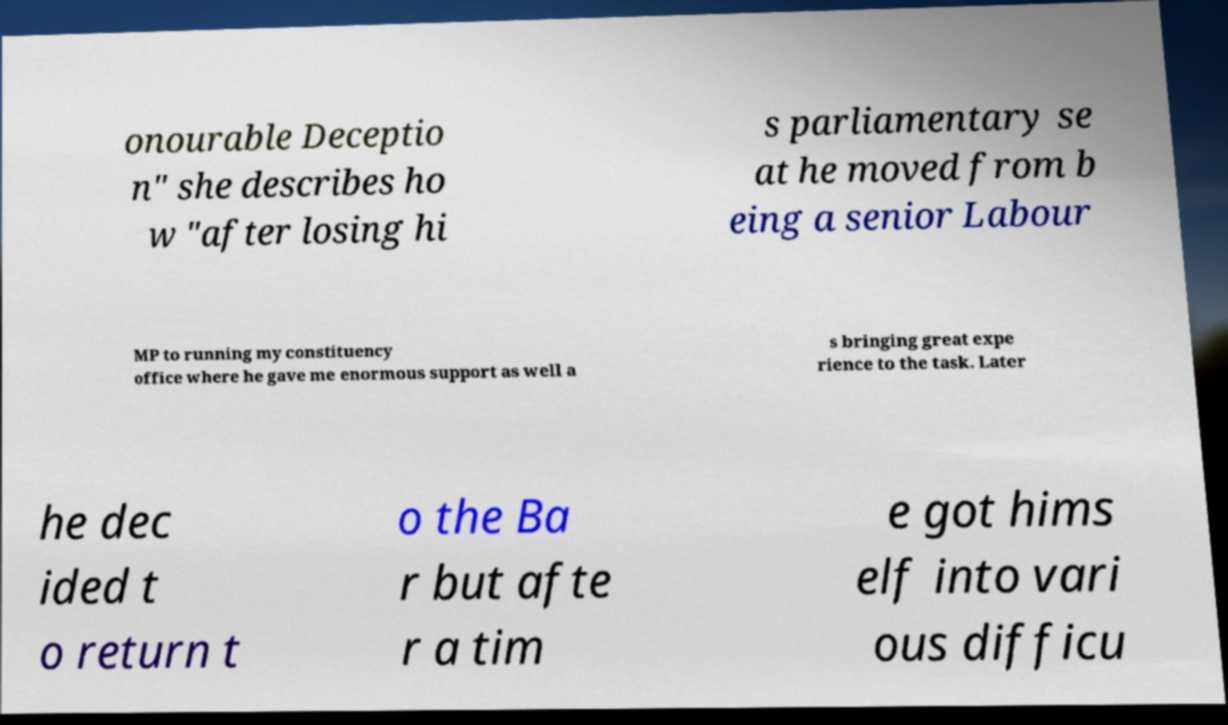Please identify and transcribe the text found in this image. onourable Deceptio n" she describes ho w "after losing hi s parliamentary se at he moved from b eing a senior Labour MP to running my constituency office where he gave me enormous support as well a s bringing great expe rience to the task. Later he dec ided t o return t o the Ba r but afte r a tim e got hims elf into vari ous difficu 